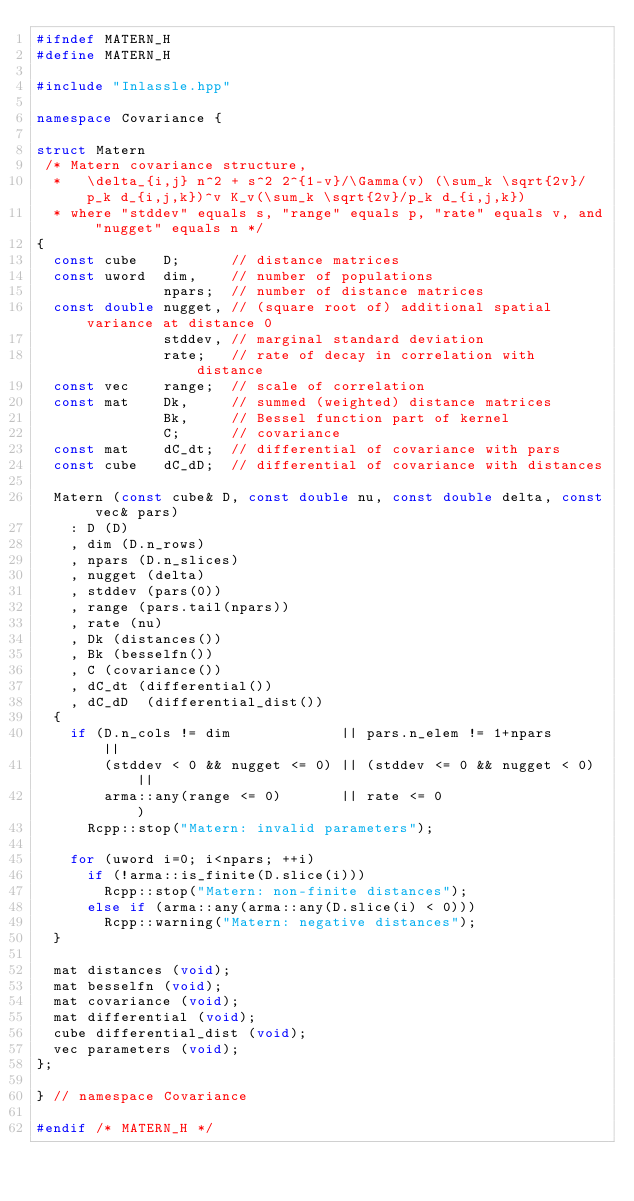Convert code to text. <code><loc_0><loc_0><loc_500><loc_500><_C++_>#ifndef MATERN_H
#define MATERN_H

#include "Inlassle.hpp"

namespace Covariance {

struct Matern
 /* Matern covariance structure,
  *   \delta_{i,j} n^2 + s^2 2^{1-v}/\Gamma(v) (\sum_k \sqrt{2v}/p_k d_{i,j,k})^v K_v(\sum_k \sqrt{2v}/p_k d_{i,j,k})
  * where "stddev" equals s, "range" equals p, "rate" equals v, and "nugget" equals n */
{
  const cube   D;      // distance matrices
  const uword  dim,    // number of populations
               npars;  // number of distance matrices
  const double nugget, // (square root of) additional spatial variance at distance 0
               stddev, // marginal standard deviation
               rate;   // rate of decay in correlation with distance
  const vec    range;  // scale of correlation
  const mat    Dk,     // summed (weighted) distance matrices
               Bk,     // Bessel function part of kernel
               C;      // covariance
  const mat    dC_dt;  // differential of covariance with pars
  const cube   dC_dD;  // differential of covariance with distances 

  Matern (const cube& D, const double nu, const double delta, const vec& pars) 
    : D (D)
    , dim (D.n_rows)
    , npars (D.n_slices)
    , nugget (delta)
    , stddev (pars(0))
    , range (pars.tail(npars))
    , rate (nu)
    , Dk (distances())
    , Bk (besselfn())
    , C (covariance())
    , dC_dt (differential())
    , dC_dD  (differential_dist())
  {
    if (D.n_cols != dim             || pars.n_elem != 1+npars      || 
        (stddev < 0 && nugget <= 0) || (stddev <= 0 && nugget < 0) || 
        arma::any(range <= 0)       || rate <= 0                   )
      Rcpp::stop("Matern: invalid parameters");

    for (uword i=0; i<npars; ++i)
      if (!arma::is_finite(D.slice(i)))
        Rcpp::stop("Matern: non-finite distances");
      else if (arma::any(arma::any(D.slice(i) < 0)))
        Rcpp::warning("Matern: negative distances");
  }

  mat distances (void);
  mat besselfn (void);
  mat covariance (void);
  mat differential (void);
  cube differential_dist (void); 
  vec parameters (void);
};

} // namespace Covariance

#endif /* MATERN_H */
</code> 